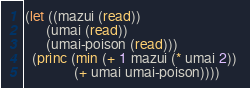Convert code to text. <code><loc_0><loc_0><loc_500><loc_500><_Lisp_>(let ((mazui (read))
      (umai (read))
      (umai-poison (read)))
  (princ (min (+ 1 mazui (* umai 2)) 
              (+ umai umai-poison))))</code> 